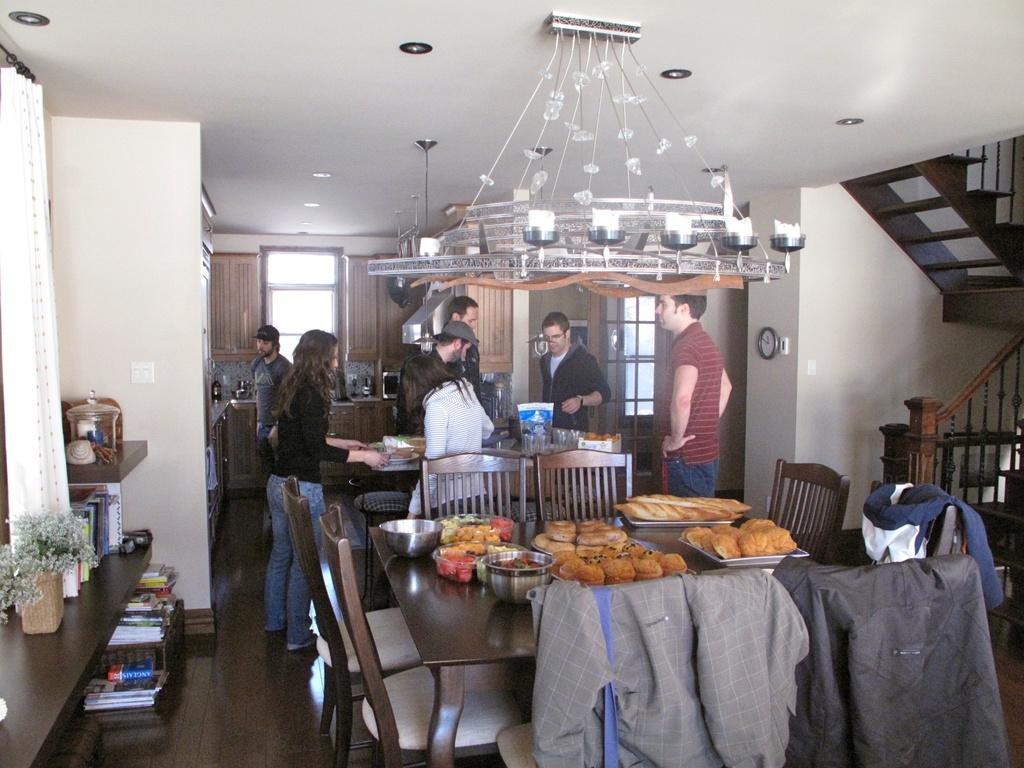In one or two sentences, can you explain what this image depicts? This image is clicked, inside the room. There are many people in this image. In the front there is a table, on which there are trays of food and bowl. And there are five empty chairs around the table. In the background, there is kitchen in which, there are cupboards. To the left, there is window, along with window curtain. To the right, there are stairs and wall. 